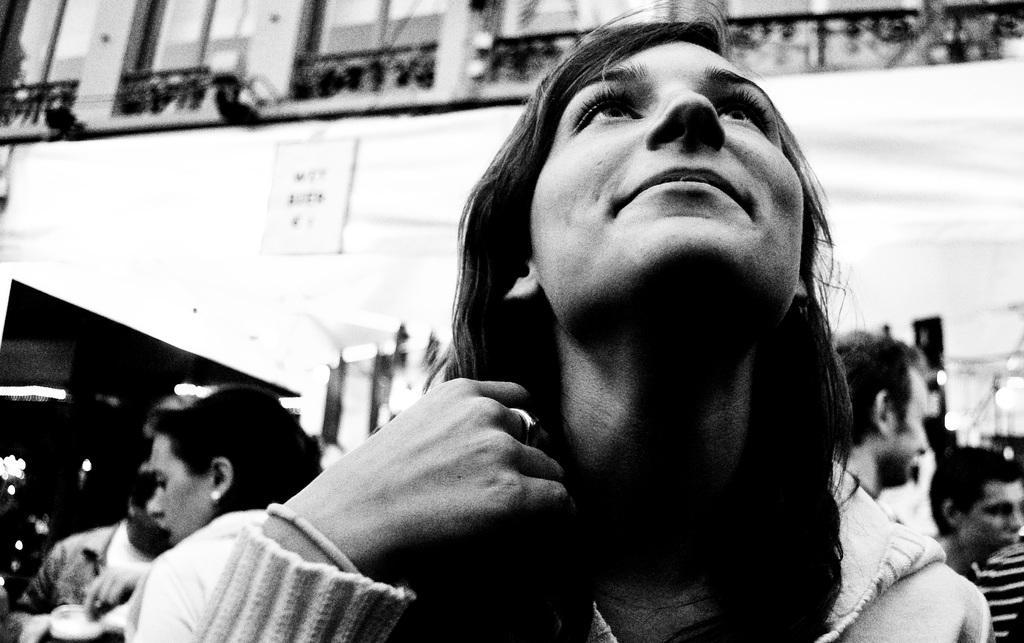Could you give a brief overview of what you see in this image? In this picture there is a woman on the front and she looks up. 